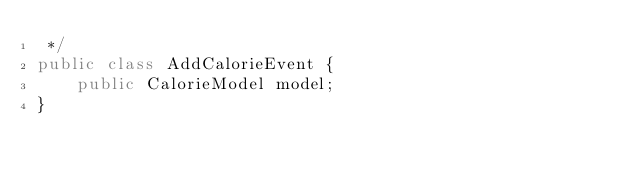<code> <loc_0><loc_0><loc_500><loc_500><_Java_> */
public class AddCalorieEvent {
    public CalorieModel model;
}
</code> 